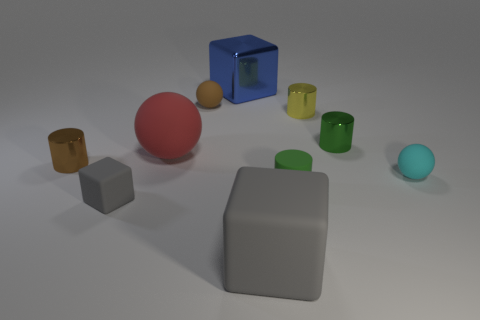Subtract all cylinders. How many objects are left? 6 Add 2 small gray shiny cubes. How many small gray shiny cubes exist? 2 Subtract 0 red cylinders. How many objects are left? 10 Subtract all cyan cylinders. Subtract all yellow shiny cylinders. How many objects are left? 9 Add 4 green rubber things. How many green rubber things are left? 5 